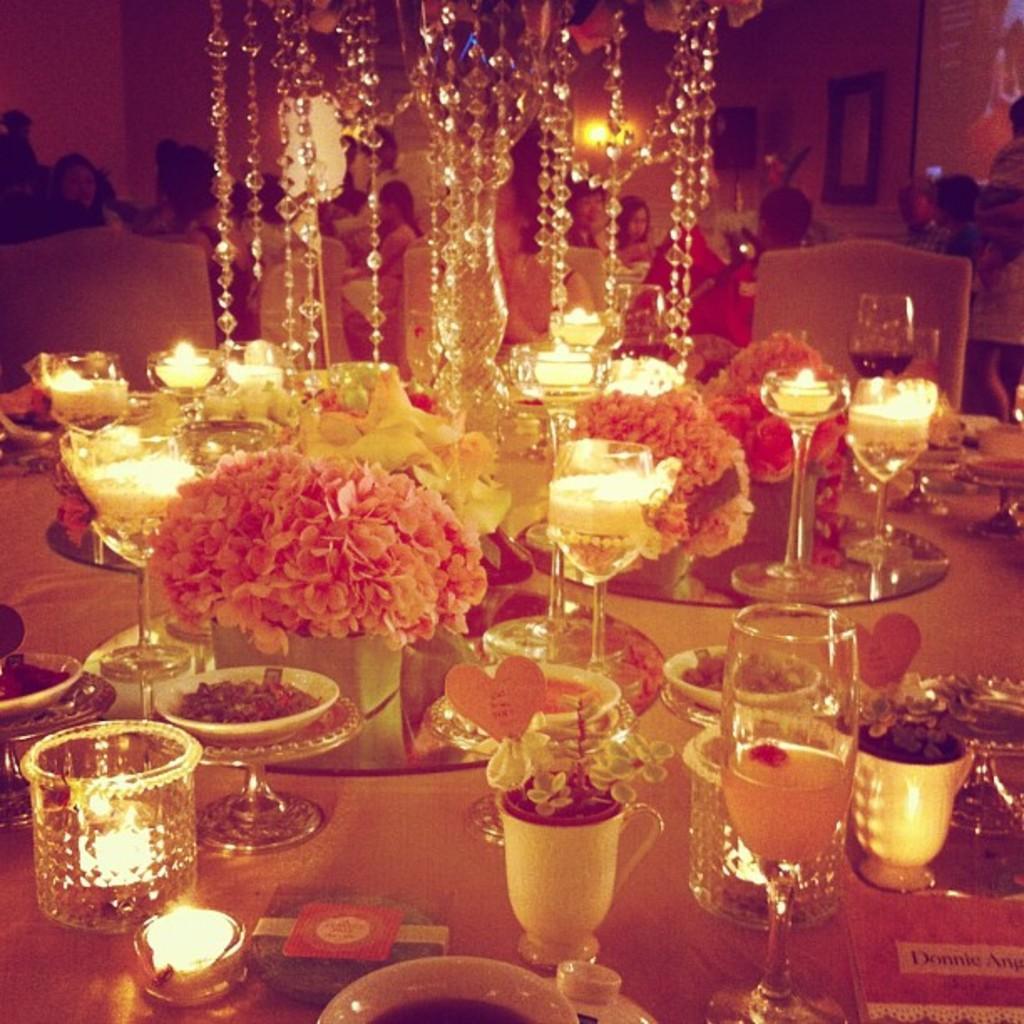Could you give a brief overview of what you see in this image? In this picture we see people seated on the chairs on the side and we see few classes candles and flowers and plates and few bowls on the table and we see a chandelier light 